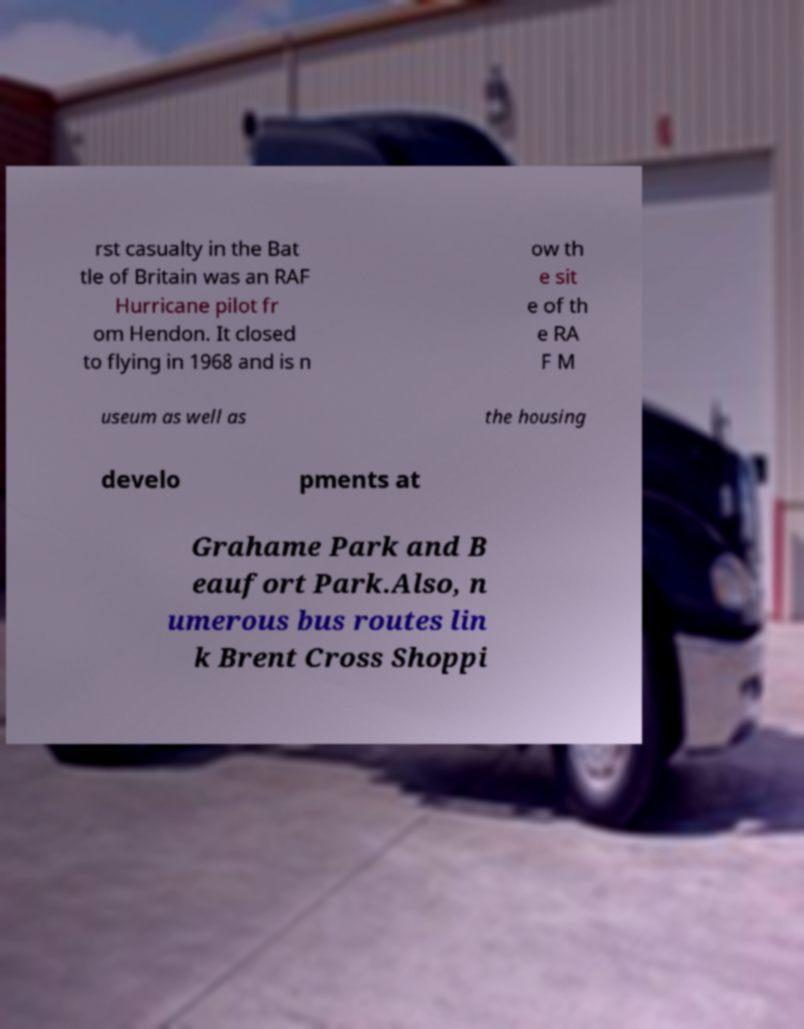There's text embedded in this image that I need extracted. Can you transcribe it verbatim? rst casualty in the Bat tle of Britain was an RAF Hurricane pilot fr om Hendon. It closed to flying in 1968 and is n ow th e sit e of th e RA F M useum as well as the housing develo pments at Grahame Park and B eaufort Park.Also, n umerous bus routes lin k Brent Cross Shoppi 